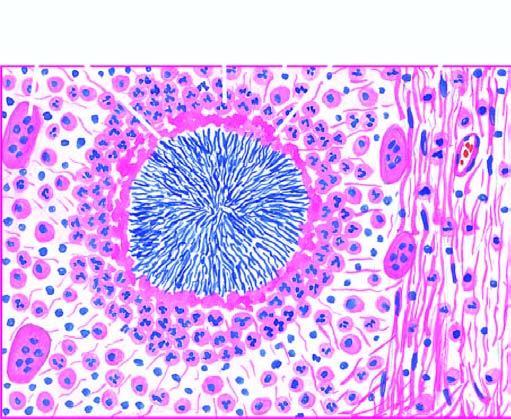does primary syphilis: primary lesion show hyaline filaments highlighted by masson 's trichrome stain right photomicrograph?
Answer the question using a single word or phrase. No 